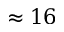<formula> <loc_0><loc_0><loc_500><loc_500>\approx 1 6</formula> 